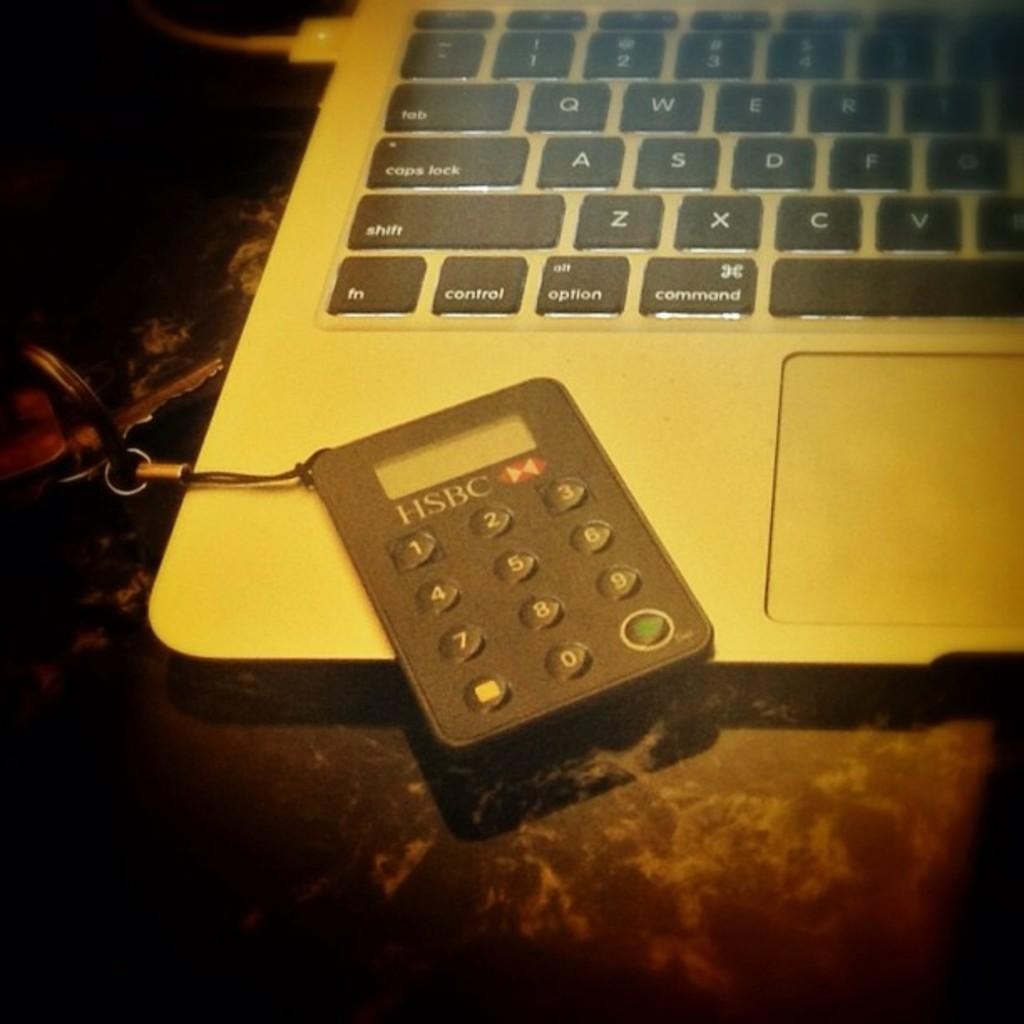Provide a one-sentence caption for the provided image. A small calculator key chain from HSBC sits on top of a laptop computer. 